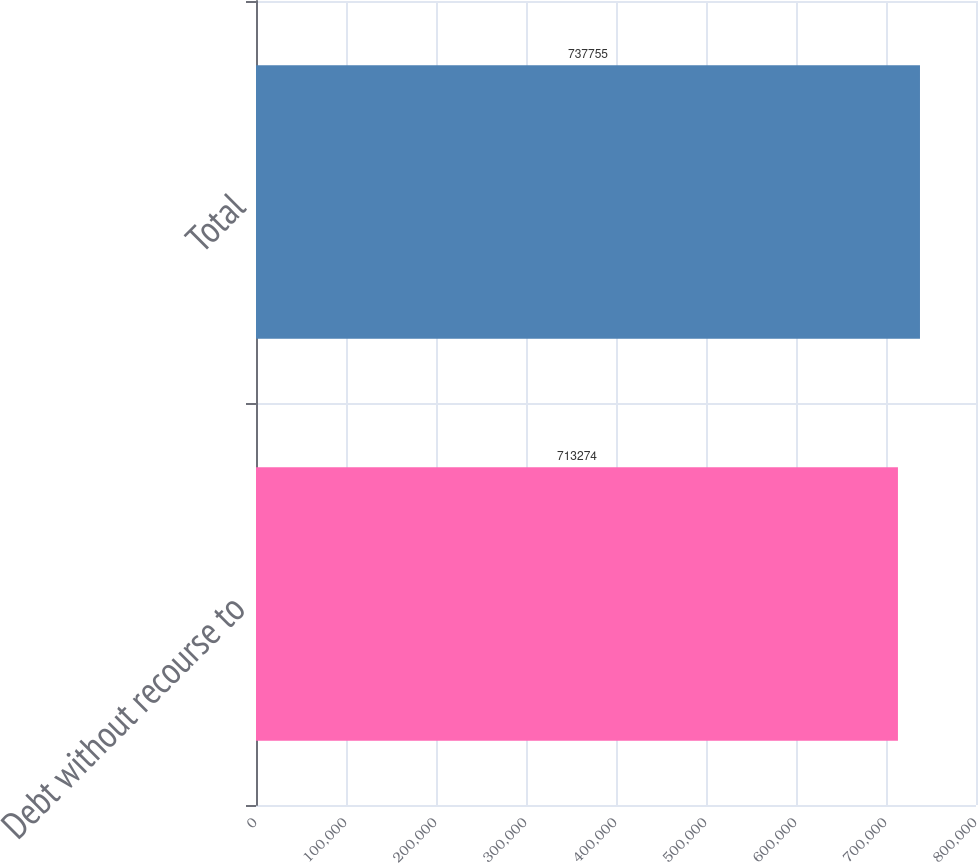Convert chart. <chart><loc_0><loc_0><loc_500><loc_500><bar_chart><fcel>Debt without recourse to<fcel>Total<nl><fcel>713274<fcel>737755<nl></chart> 